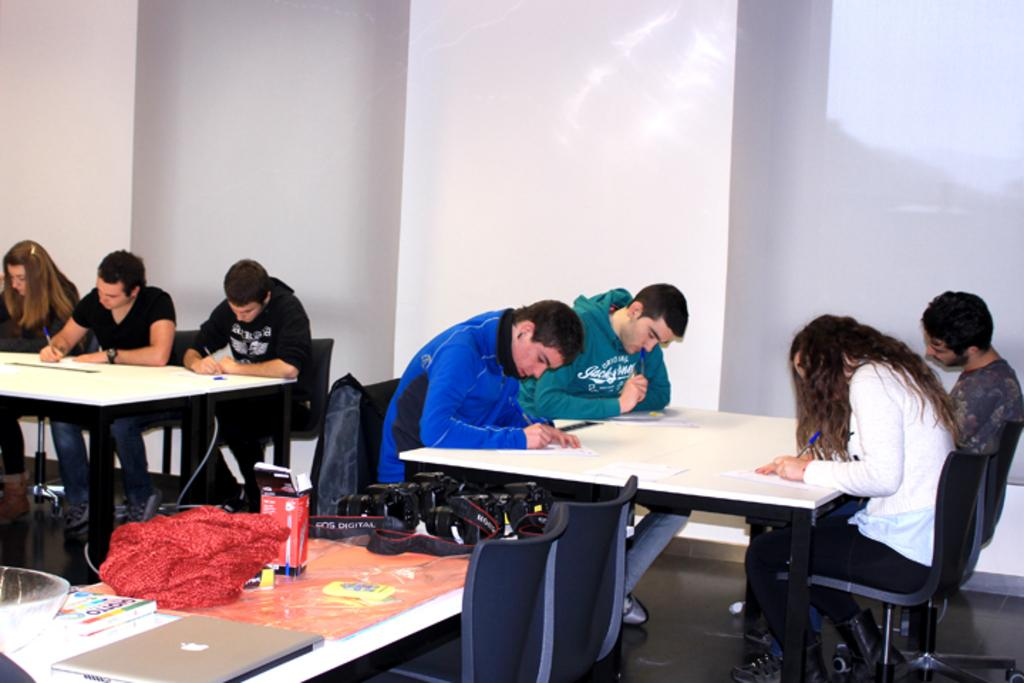What are the people in the image doing? The people in the image are sitting on chairs and writing on paper with pens. Can you describe the setting in which the people are writing? The setting is not specified in the facts, but we know that the people are sitting on chairs while writing. What type of frog can be seen hopping across the paper in the image? There is no frog present in the image; the people are writing on paper with pens. How deep is the quicksand in the image? There is no quicksand present in the image; the people are sitting on chairs and writing on paper with pens. 